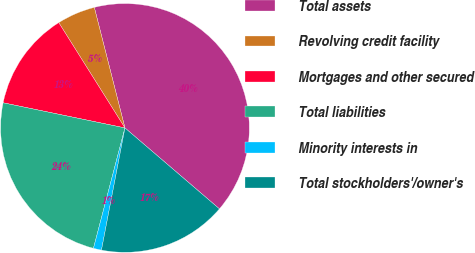Convert chart. <chart><loc_0><loc_0><loc_500><loc_500><pie_chart><fcel>Total assets<fcel>Revolving credit facility<fcel>Mortgages and other secured<fcel>Total liabilities<fcel>Minority interests in<fcel>Total stockholders'/owner's<nl><fcel>40.24%<fcel>4.97%<fcel>12.83%<fcel>24.17%<fcel>1.05%<fcel>16.75%<nl></chart> 